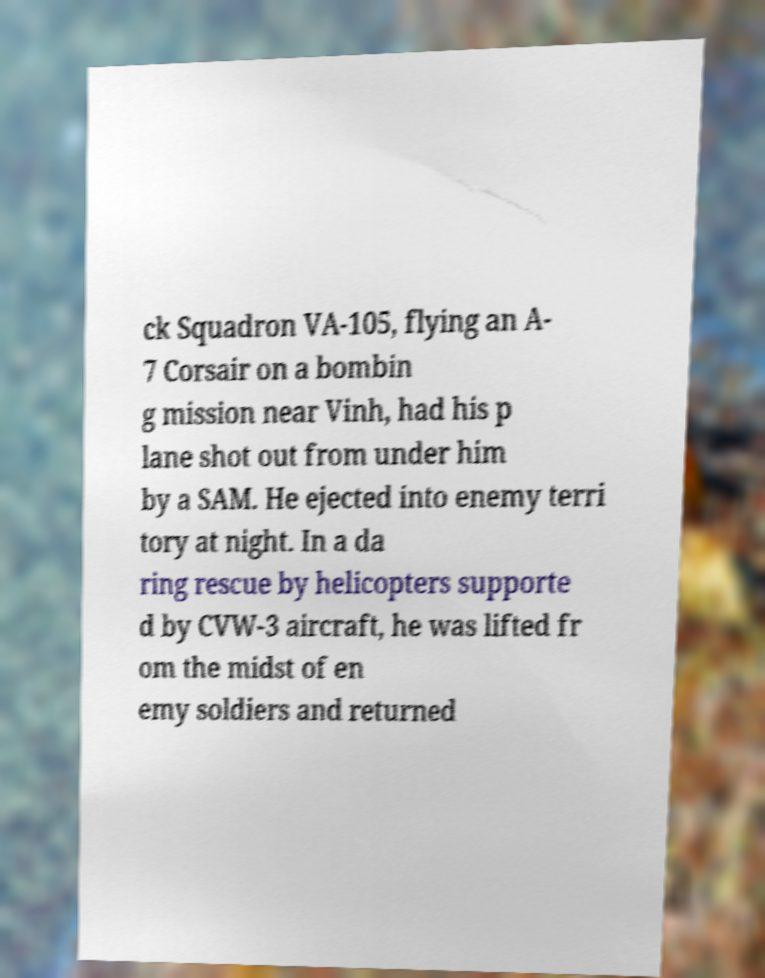I need the written content from this picture converted into text. Can you do that? ck Squadron VA-105, flying an A- 7 Corsair on a bombin g mission near Vinh, had his p lane shot out from under him by a SAM. He ejected into enemy terri tory at night. In a da ring rescue by helicopters supporte d by CVW-3 aircraft, he was lifted fr om the midst of en emy soldiers and returned 